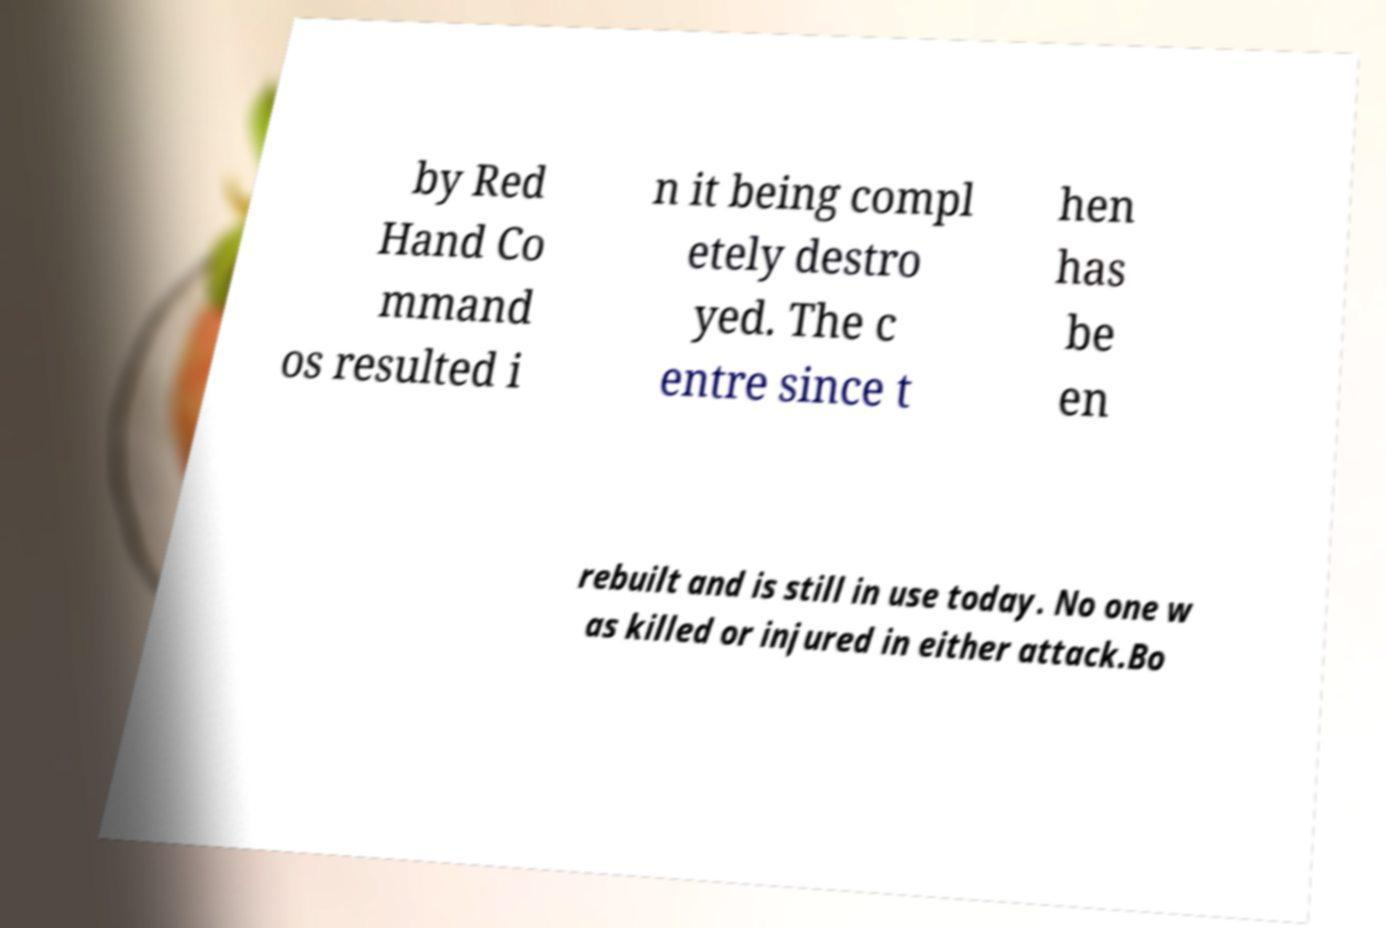What messages or text are displayed in this image? I need them in a readable, typed format. by Red Hand Co mmand os resulted i n it being compl etely destro yed. The c entre since t hen has be en rebuilt and is still in use today. No one w as killed or injured in either attack.Bo 